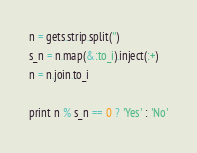<code> <loc_0><loc_0><loc_500><loc_500><_Ruby_>n = gets.strip.split('')
s_n = n.map(&:to_i).inject(:+)
n = n.join.to_i

print n % s_n == 0 ? 'Yes' : 'No'</code> 